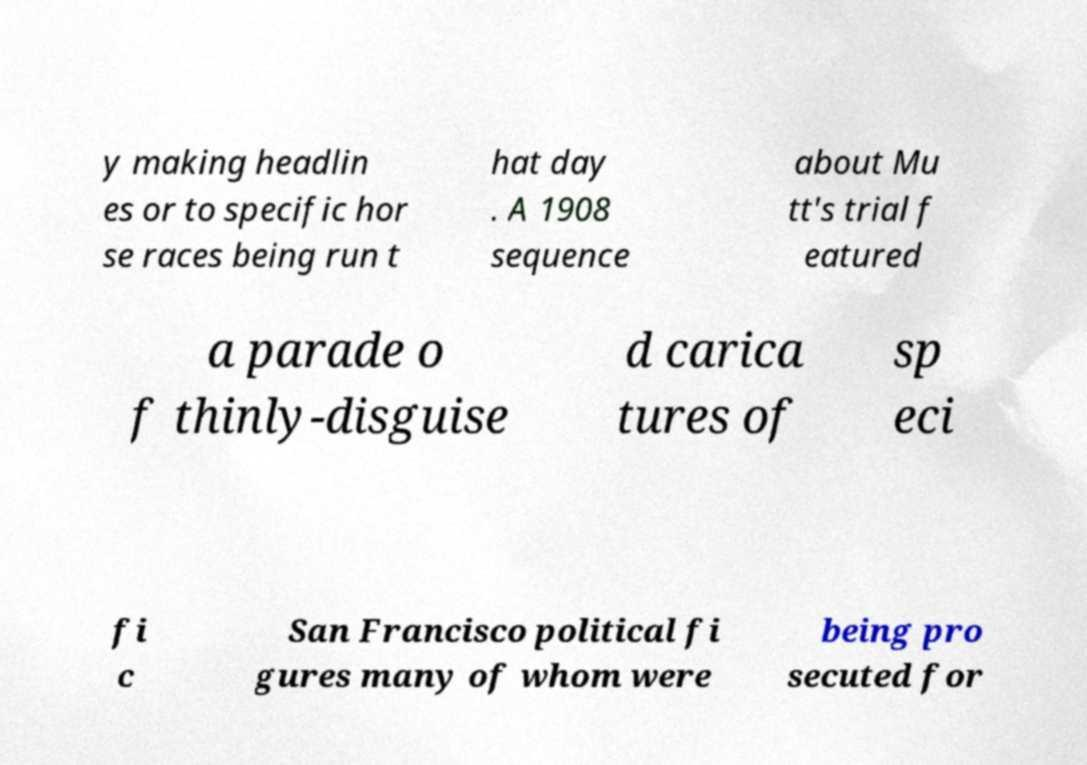Can you read and provide the text displayed in the image?This photo seems to have some interesting text. Can you extract and type it out for me? y making headlin es or to specific hor se races being run t hat day . A 1908 sequence about Mu tt's trial f eatured a parade o f thinly-disguise d carica tures of sp eci fi c San Francisco political fi gures many of whom were being pro secuted for 